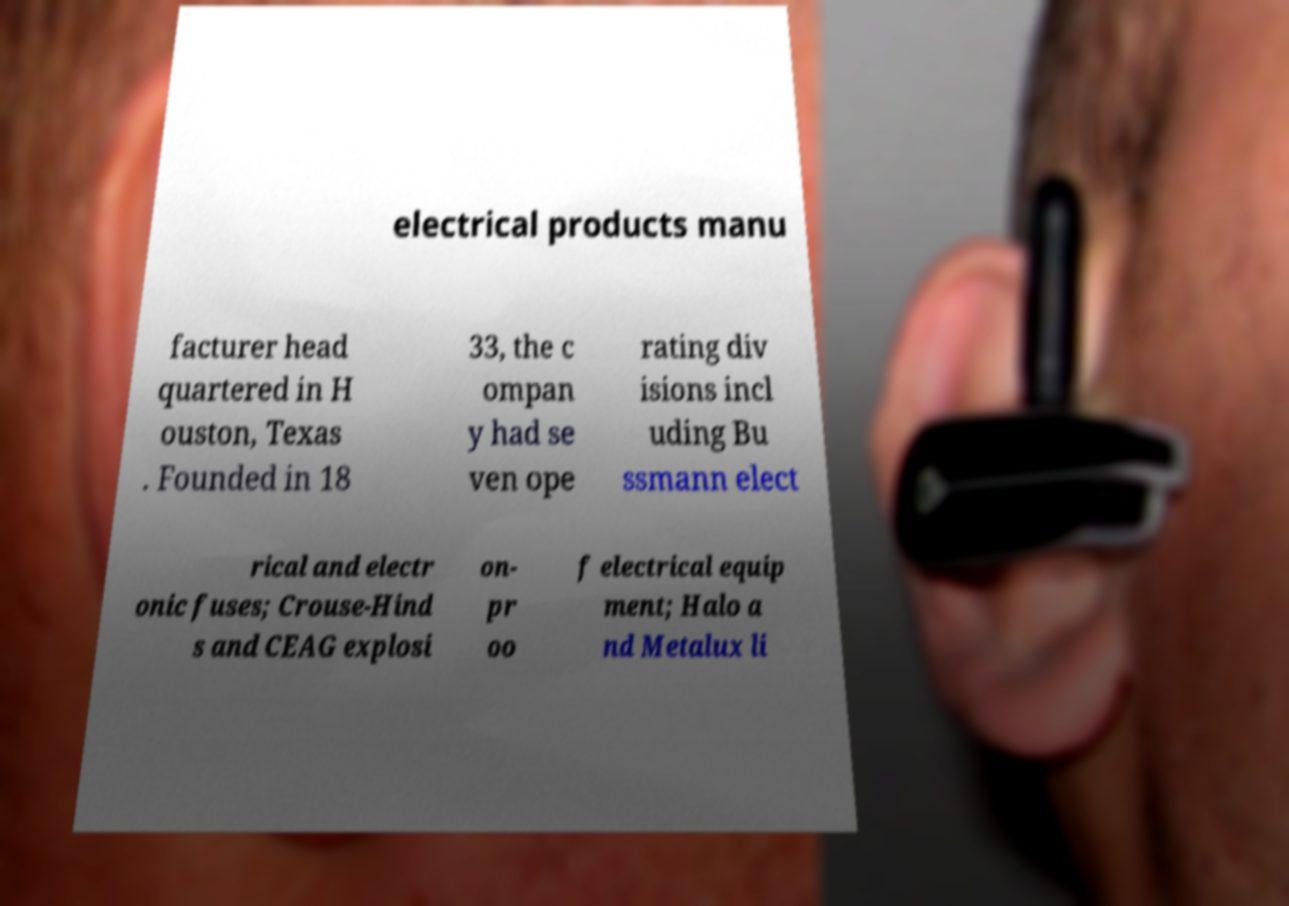Could you assist in decoding the text presented in this image and type it out clearly? electrical products manu facturer head quartered in H ouston, Texas . Founded in 18 33, the c ompan y had se ven ope rating div isions incl uding Bu ssmann elect rical and electr onic fuses; Crouse-Hind s and CEAG explosi on- pr oo f electrical equip ment; Halo a nd Metalux li 